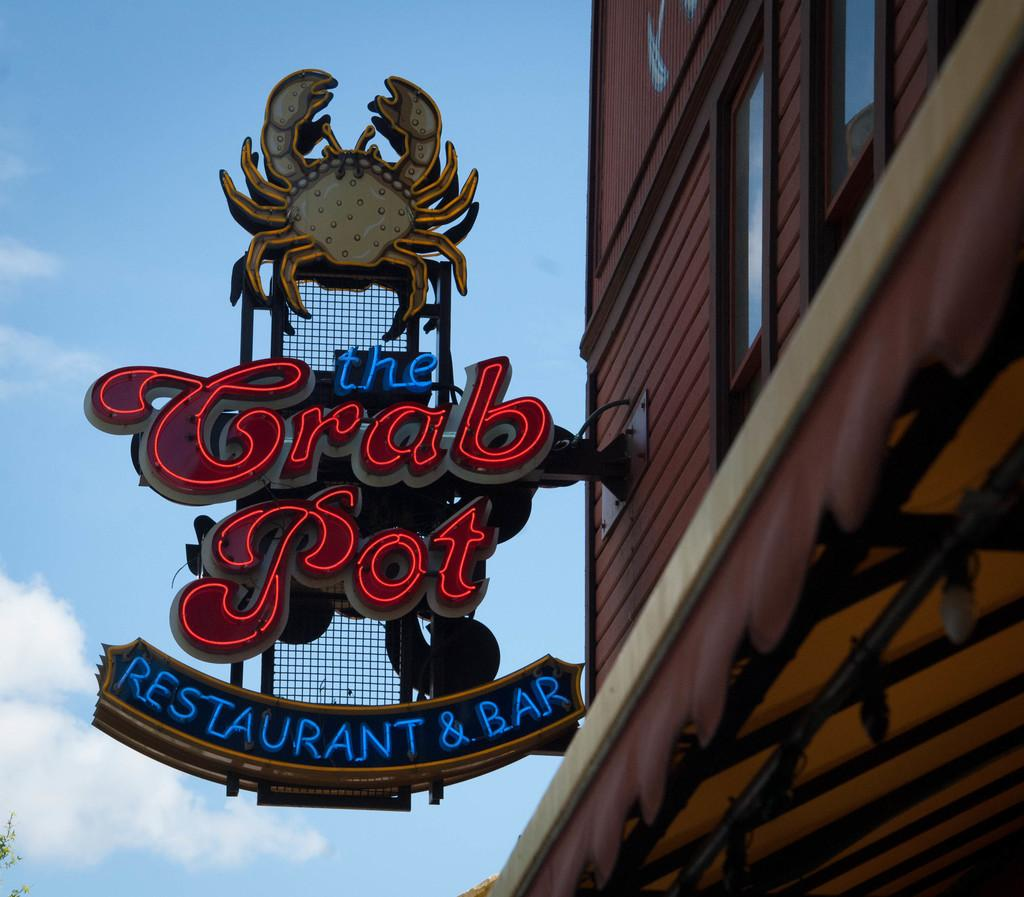What type of structure is visible in the image? There is a building in the image. What feature can be observed on the building? The building has glass windows. What is attached to the building's wall? There is a hoarding attached to the building's wall. What can be seen in the background of the image? There is a tree in the background of the image. How would you describe the sky in the image? The sky is blue and has clouds in it. What type of tub can be seen in the image? There is no tub present in the image. How many beads are hanging from the tree in the image? There are no beads hanging from the tree in the image; it is a natural tree with no decorations. 